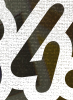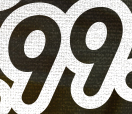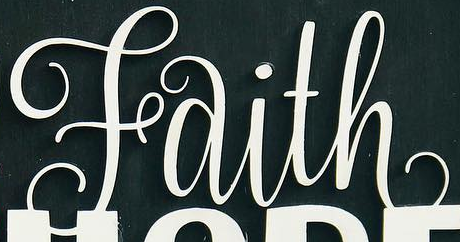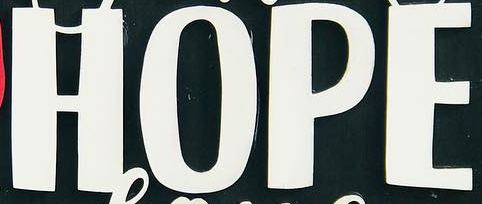What words are shown in these images in order, separated by a semicolon? 4; 99; Faith; HOPE 